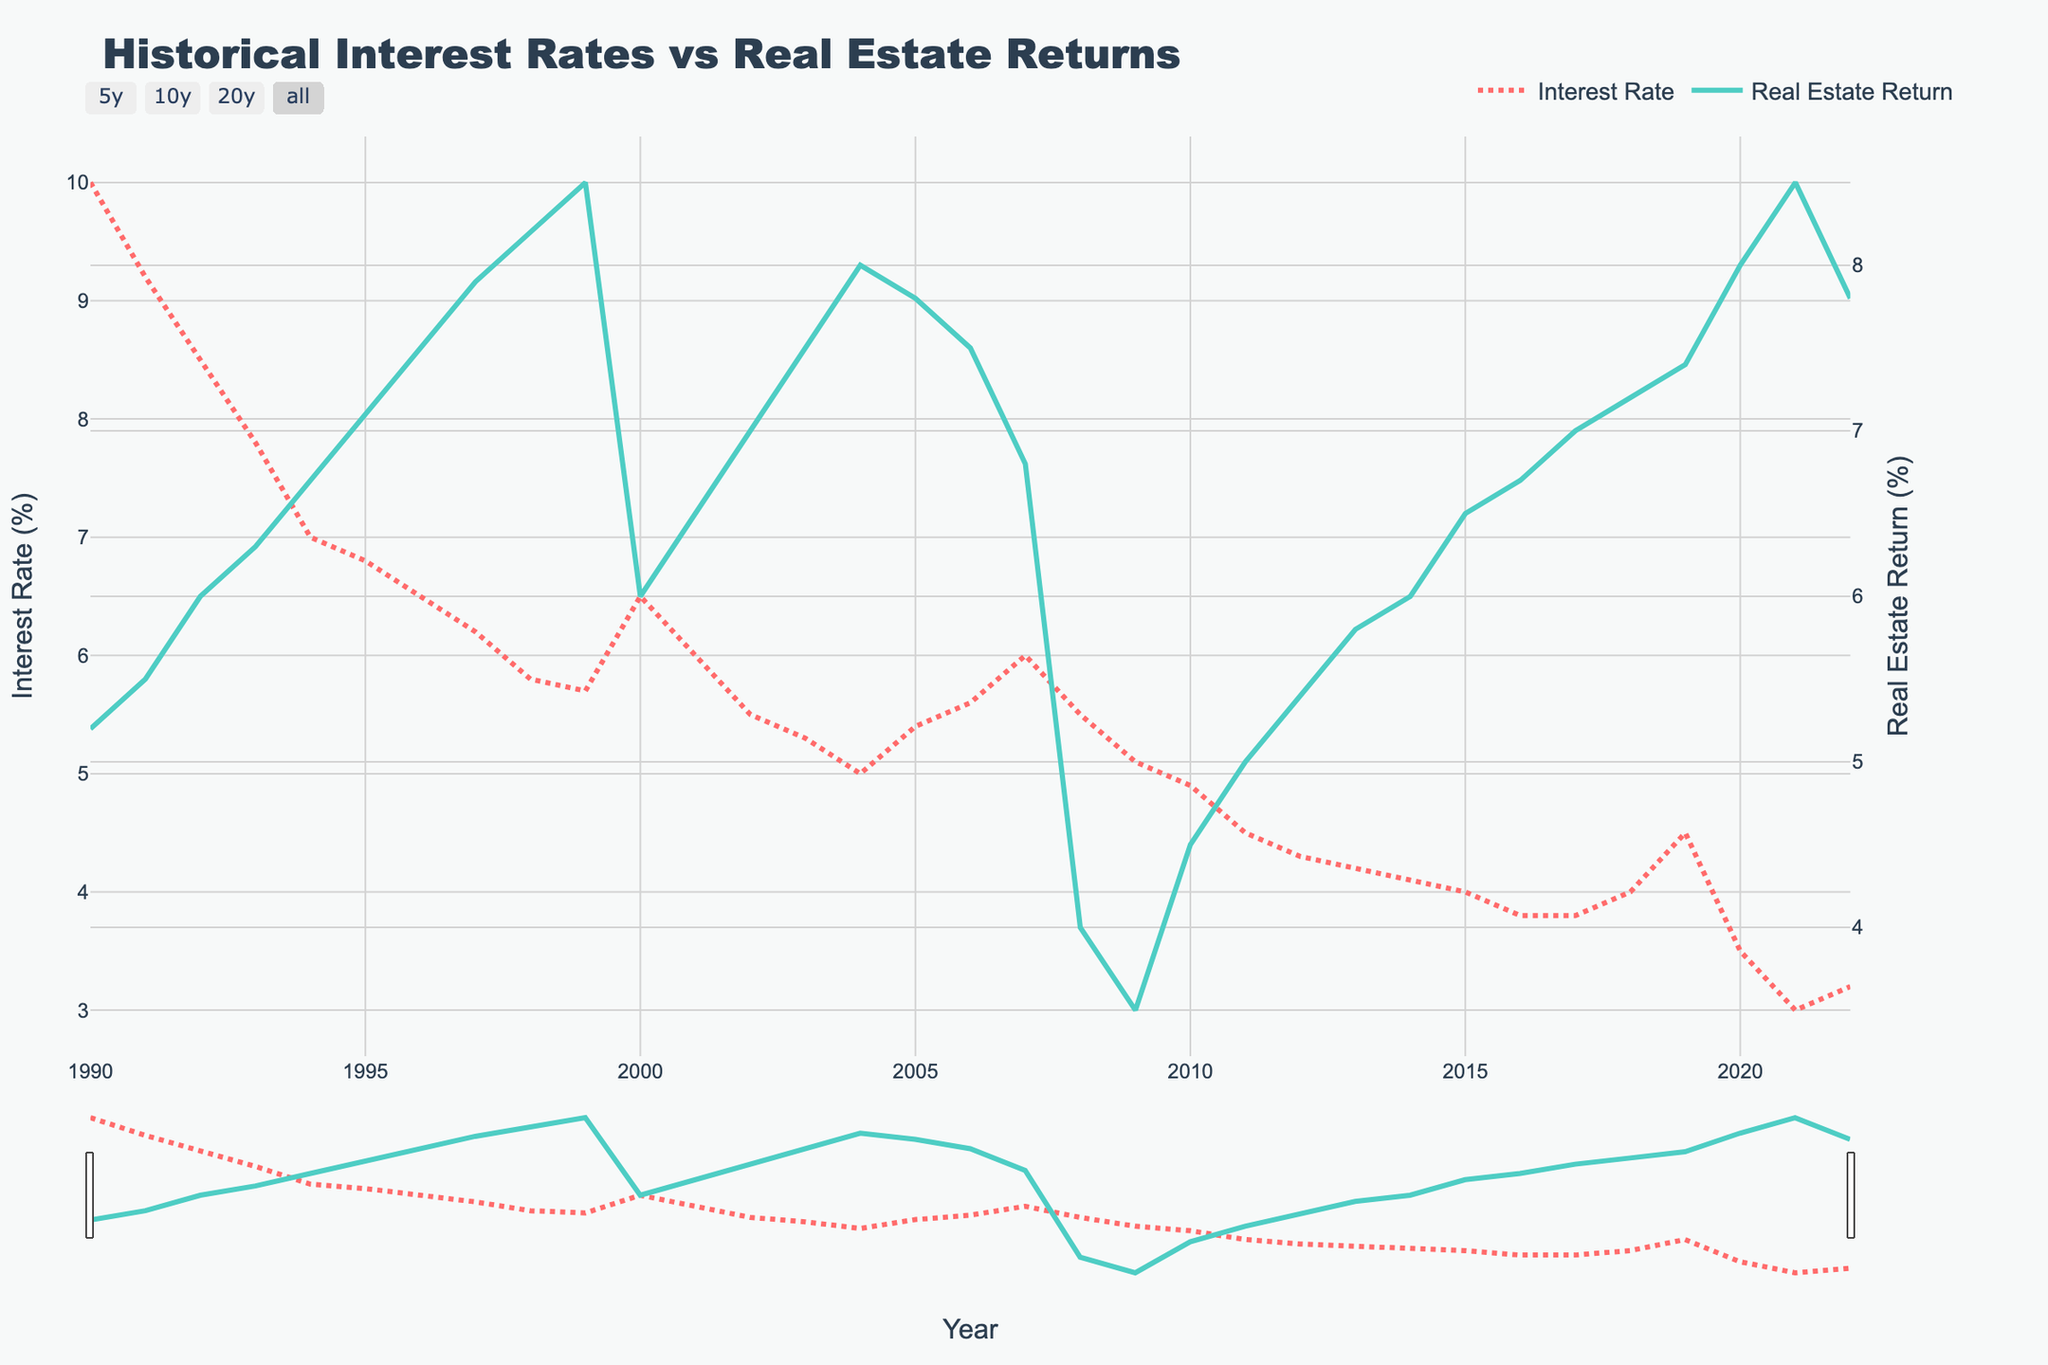What's the title of the plot? The title is usually displayed at the top center of the plot. Here, the title reads "Historical Interest Rates vs Real Estate Returns".
Answer: Historical Interest Rates vs Real Estate Returns What are the y-axes titles? There are two y-axes, one on the left and one on the right. The left y-axis title is "Interest Rate (%)", and the right y-axis title is "Real Estate Return (%)".
Answer: Interest Rate (%) and Real Estate Return (%) What trend can you observe for the interest rates over time? To identify the trend, look at the line representing interest rates from 1990 to 2022. The interest rates generally decrease over the years with some fluctuations.
Answer: Decreasing trend How do real estate returns behave as interest rates decrease between 1995 and 1999? Track the interval from 1995 to 1999 on both the interest rate and real estate return lines. Interest rates decline from around 6.8% to 5.7%, and real estate returns increase from about 7.1% to 8.5%.
Answer: Real estate returns increase Which year had the lowest real estate return and what was the interest rate that year? Identify the lowest point on the real estate return line and note the corresponding year, then check the interest rate for that year. In 2009, the real estate return was the lowest at 3.5% with an interest rate of 5.1%.
Answer: 2009, 5.1% What is the relationship between interest rates and real estate returns in 2020? Look for the values of interest rates and real estate returns in the year 2020. The interest rate is 3.5% and the real estate return is 8.0%. Low interest rates coincide with high real estate returns.
Answer: Low interest rate, high return Calculate the average interest rate from 1990 to 2000. Sum the interest rates from 1990 to 2000 and divide by the number of years (11). Average = (10.0 + 9.2 + 8.5 + 7.8 + 7.0 + 6.8 + 6.5 + 6.2 + 5.8 + 5.7 + 6.5) / 11 = 7.36%.
Answer: 7.36% What's the difference in real estate return between 2000 and 2021? Subtract the real estate return in 2000 from that in 2021. Difference = 8.5% - 6.0% = 2.5%.
Answer: 2.5% In which year did the interest rate and real estate return both decrease? Check the trend of both lines for simultaneous decreases. In 2008, both interest rates (from 6.0% to 5.5%) and real estate returns (from 6.8% to 4.0%) decreased.
Answer: 2008 